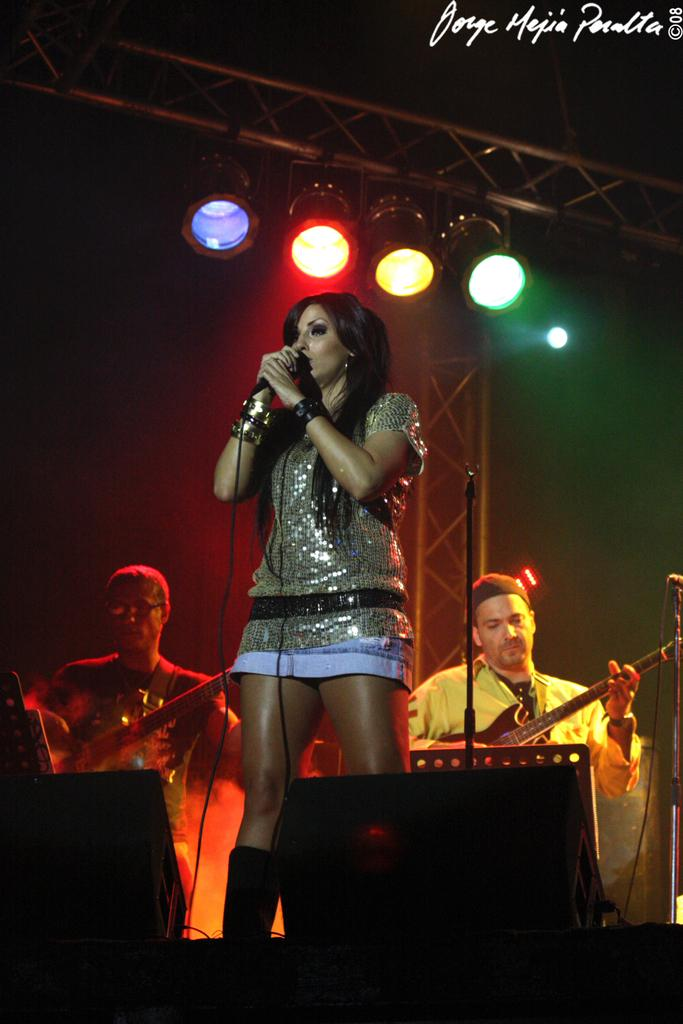Who is the main subject in the image? There is a woman in the image. What is the woman holding in the image? The woman is holding a microphone. What are the two men in the background doing? The two men in the background are playing guitars. What additional objects can be seen in the image? There are rods and lights visible in the image. What type of list can be seen in the image? There is no list present in the image. Can you see an airplane or a volcano in the image? No, neither an airplane nor a volcano is present in the image. 